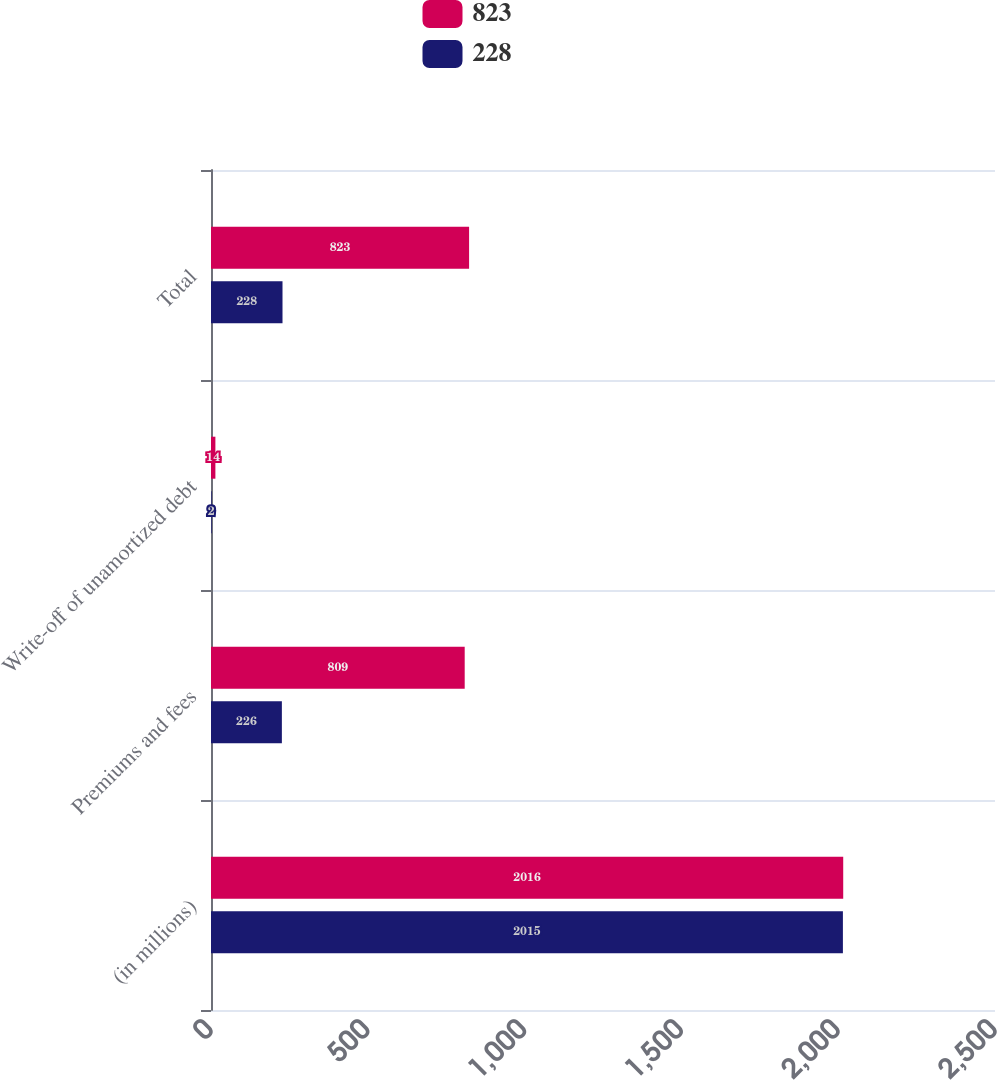Convert chart. <chart><loc_0><loc_0><loc_500><loc_500><stacked_bar_chart><ecel><fcel>(in millions)<fcel>Premiums and fees<fcel>Write-off of unamortized debt<fcel>Total<nl><fcel>823<fcel>2016<fcel>809<fcel>14<fcel>823<nl><fcel>228<fcel>2015<fcel>226<fcel>2<fcel>228<nl></chart> 